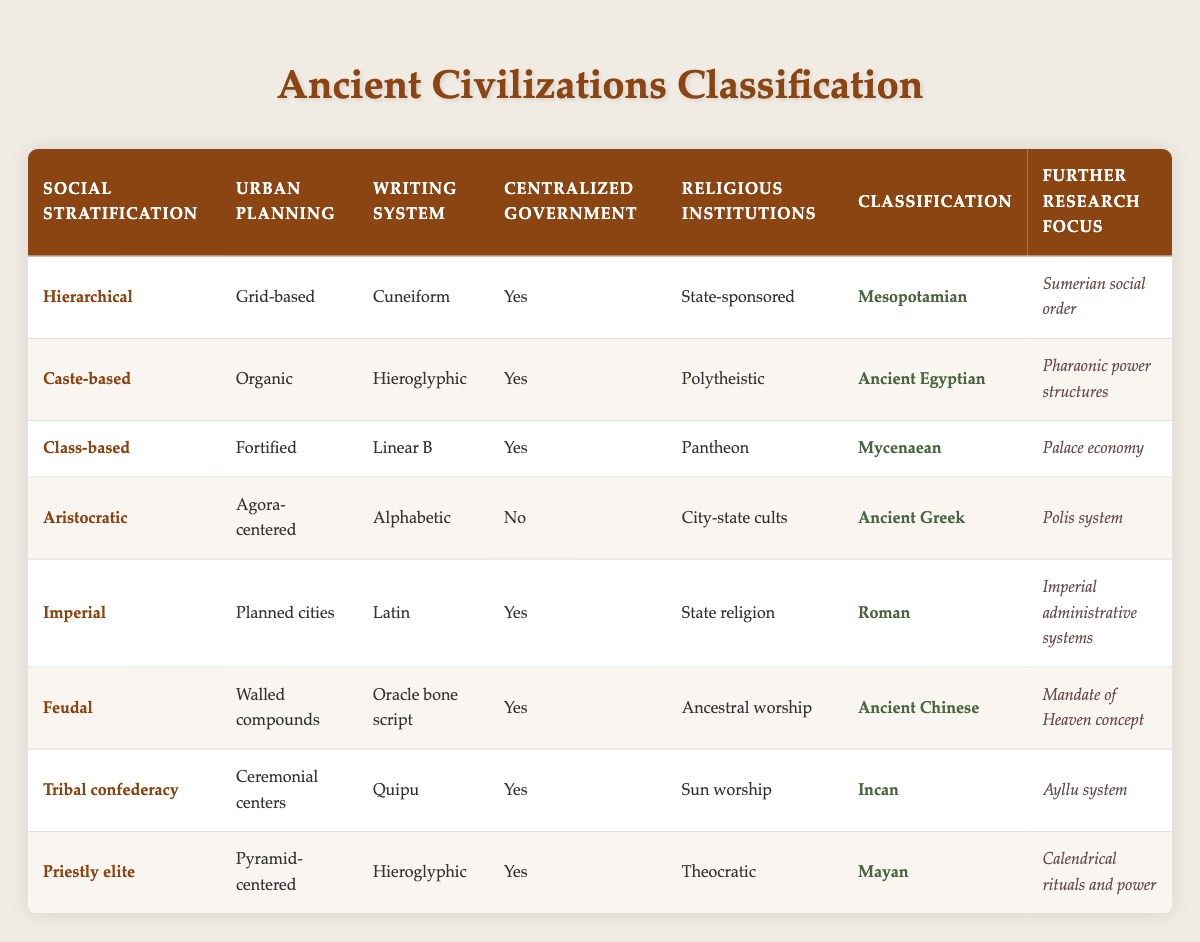What civilization has a hierarchical social stratification? By looking for the "Social Stratification" column, we can identify the rows where "Hierarchical" is specified. Only one civilization fits this criterion, which is Mesopotamian.
Answer: Mesopotamian Is there any civilization with no centralized government? The "Centralized Government" column can be checked for the presence of a "No" entry. Upon reviewing the table, the only civilization that shows "No" for this criterion is Ancient Greek.
Answer: Yes Which civilizations practiced state-sponsored religious institutions? We examine the "Religious Institutions" column for entries labeled as "State-sponsored." In the table, two civilizations meet this condition: Mesopotamian and Roman.
Answer: Mesopotamian and Roman How many civilizations utilized a writing system that is alphabetic? We can look through the "Writing System" column and count instances of "Alphabetic." From the table, only Ancient Greek is listed with this type.
Answer: 1 Among the civilizations listed, which one has its further research focus on the Mandate of Heaven concept? By checking the "Further Research Focus" column, we can find which civilization corresponds to the focus on the Mandate of Heaven, which is clearly labeled for Ancient Chinese.
Answer: Ancient Chinese What is the difference in social stratification types between the Incan and Mayan civilizations? We need to compare the "Social Stratification" entries for both civilizations. The Incan civilization has a "Tribal confederacy" while the Mayan civilization has a "Priestly elite." The difference is that one is more decentralized and tribal while the other is more elite and priestly centered.
Answer: Tribal confederacy and Priestly elite Which civilization had fortified urban planning but was class-based in social stratification? Searching the "Urban Planning" column for "Fortified" and cross-referencing with the "Social Stratification" column indicates that only the Mycenaean civilization fits this criterion.
Answer: Mycenaean Are there any civilizations that have both a grid-based urban planning and a writing system that is cuneiform? By examining the relevant columns, we can see that only the Mesopotamian civilization meets both criteria, indicating it has grid-based urban planning and uses cuneiform writing.
Answer: Yes 